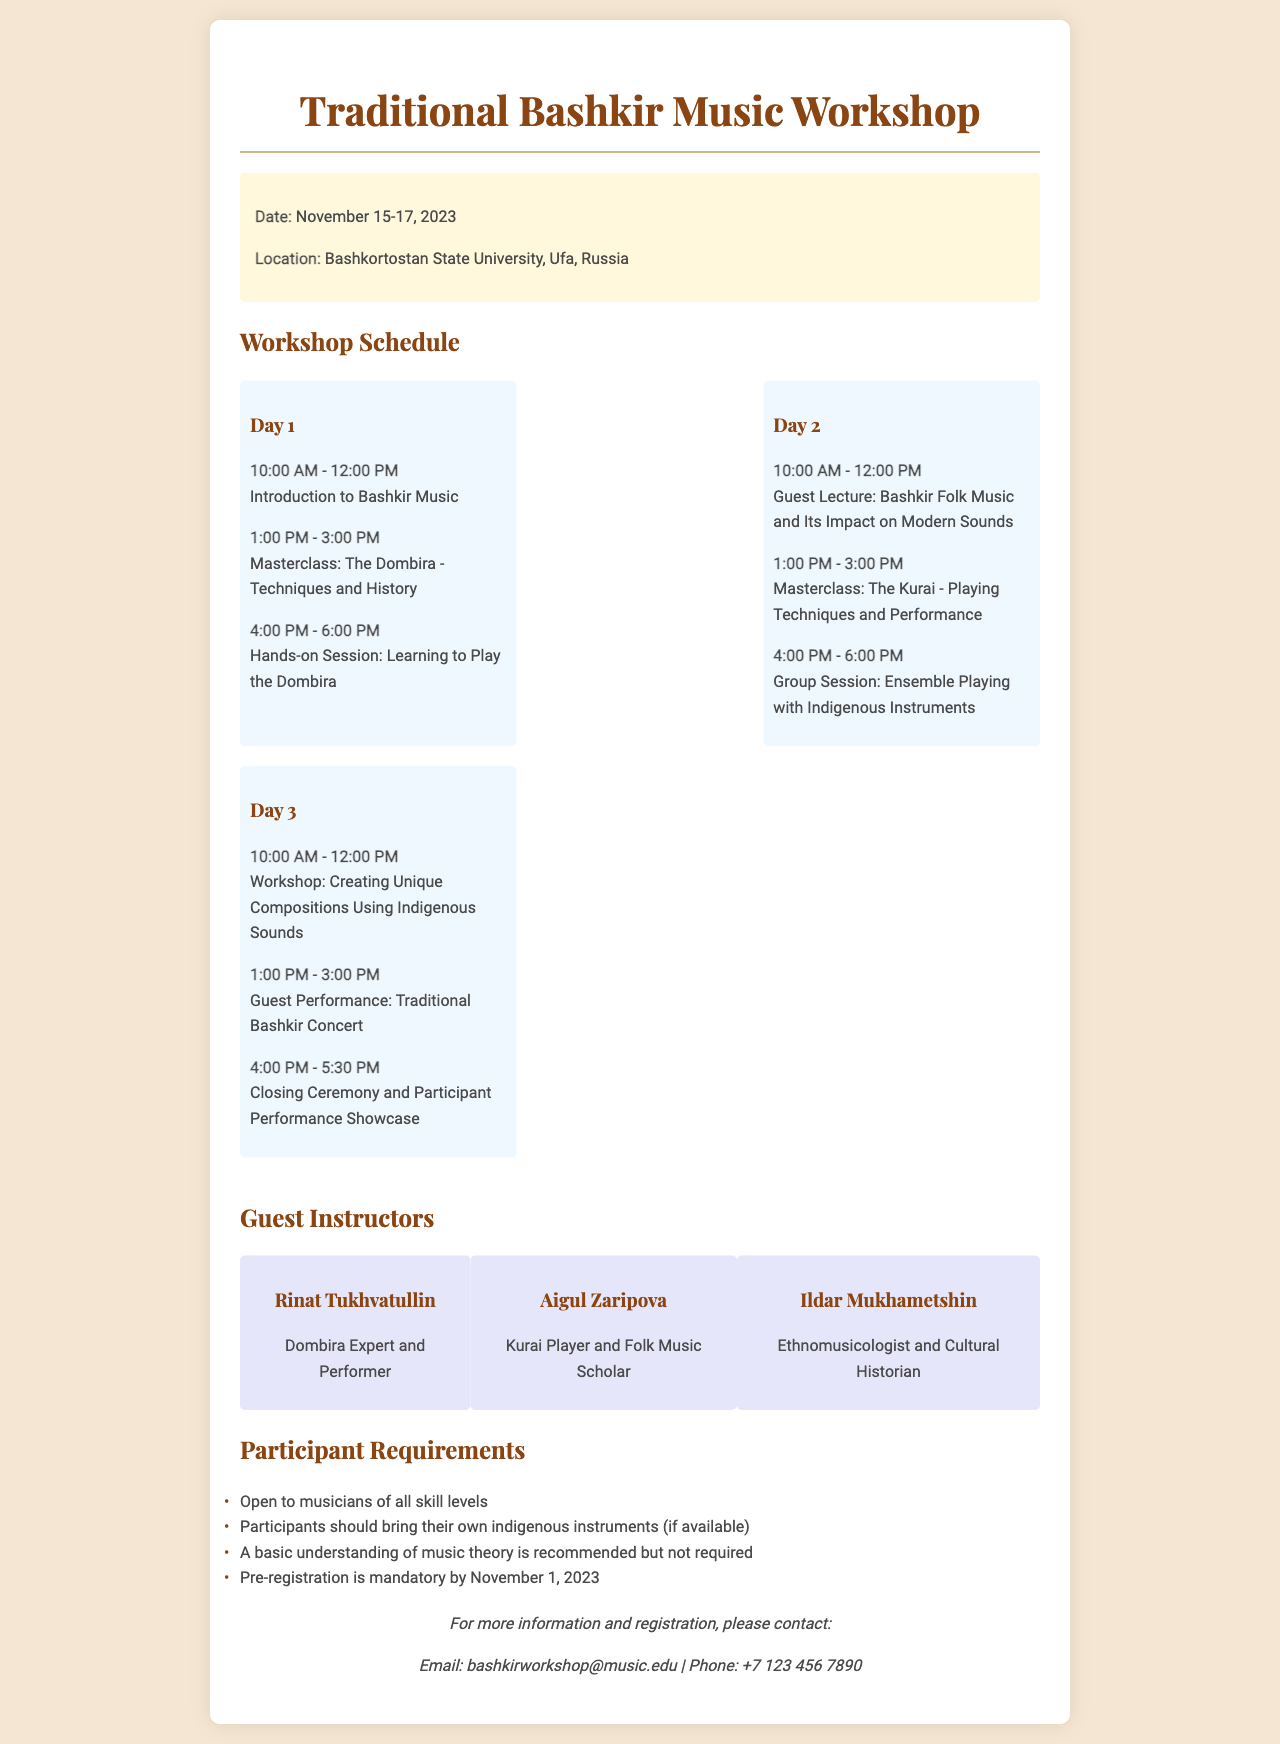What are the dates of the workshop? The dates of the workshop are directly mentioned in the document.
Answer: November 15-17, 2023 Who is the expert on the Dombira? The document lists the instructors and specifies who is an expert in Dombira.
Answer: Rinat Tukhvatullin What is recommended for participants regarding music theory? The document states the requirements for participants, including knowledge of music theory.
Answer: A basic understanding How many guest instructors are featured in the workshop? The number of guest instructors can be counted from the section in the document.
Answer: Three What time does the closing ceremony start on Day 3? The document provides the schedule for Day 3, including the start time of the closing ceremony.
Answer: 4:00 PM Is pre-registration required for the workshop? The requirements clearly mention whether pre-registration is mandatory or optional.
Answer: Mandatory Which instrument is covered in the Day 2 masterclass? The specific instrument for Day 2's masterclass is mentioned in the workshop schedule.
Answer: Kurai Where is the workshop taking place? The location of the workshop is stated in the event details of the document.
Answer: Bashkortostan State University, Ufa, Russia 